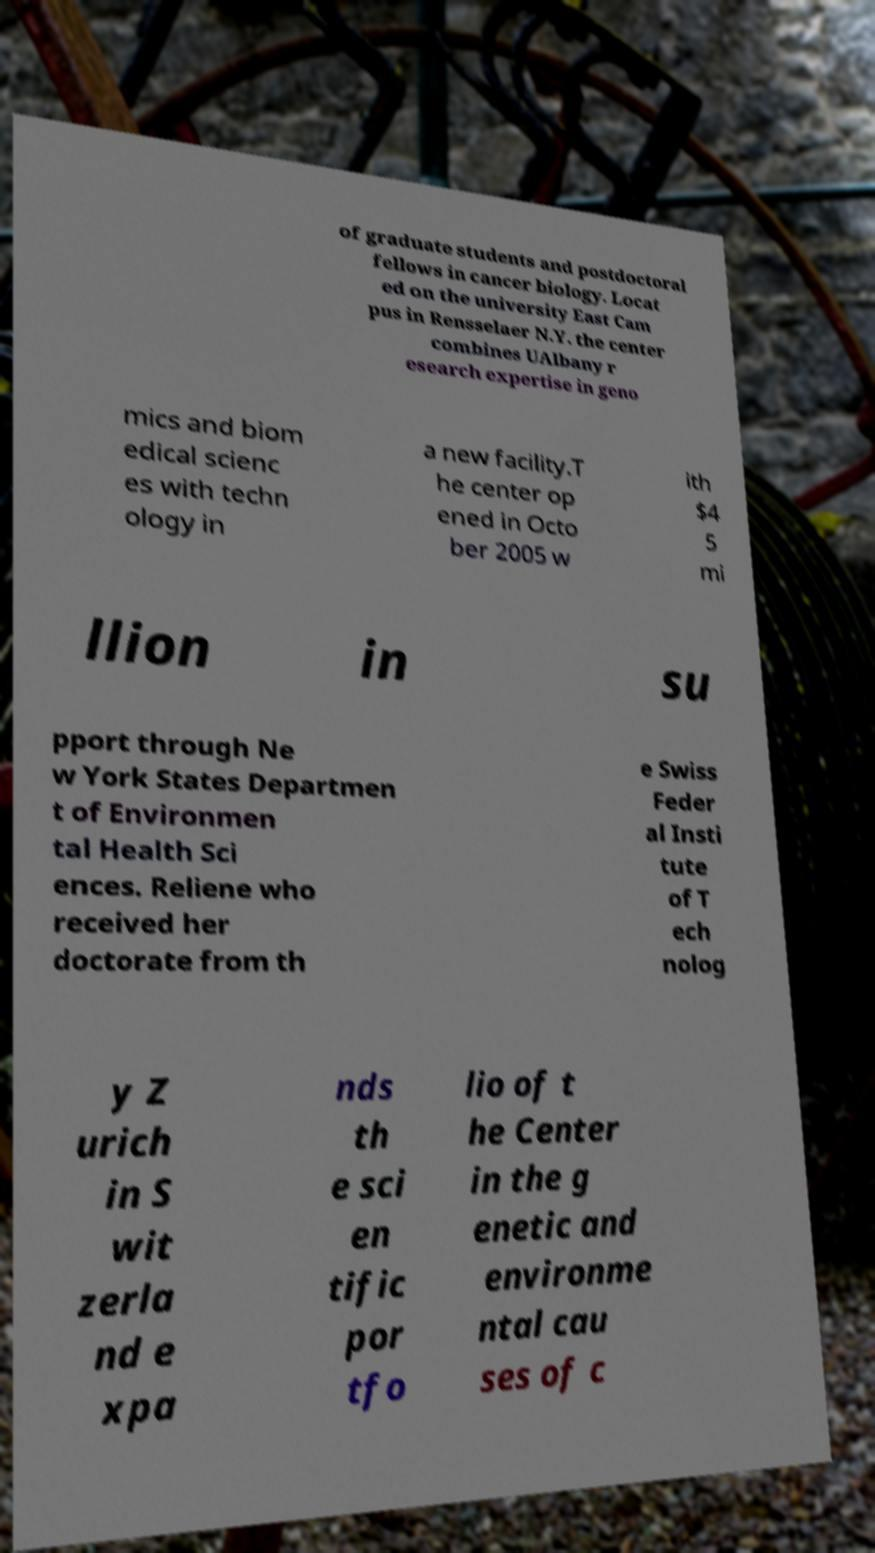What messages or text are displayed in this image? I need them in a readable, typed format. of graduate students and postdoctoral fellows in cancer biology. Locat ed on the university East Cam pus in Rensselaer N.Y. the center combines UAlbany r esearch expertise in geno mics and biom edical scienc es with techn ology in a new facility.T he center op ened in Octo ber 2005 w ith $4 5 mi llion in su pport through Ne w York States Departmen t of Environmen tal Health Sci ences. Reliene who received her doctorate from th e Swiss Feder al Insti tute of T ech nolog y Z urich in S wit zerla nd e xpa nds th e sci en tific por tfo lio of t he Center in the g enetic and environme ntal cau ses of c 